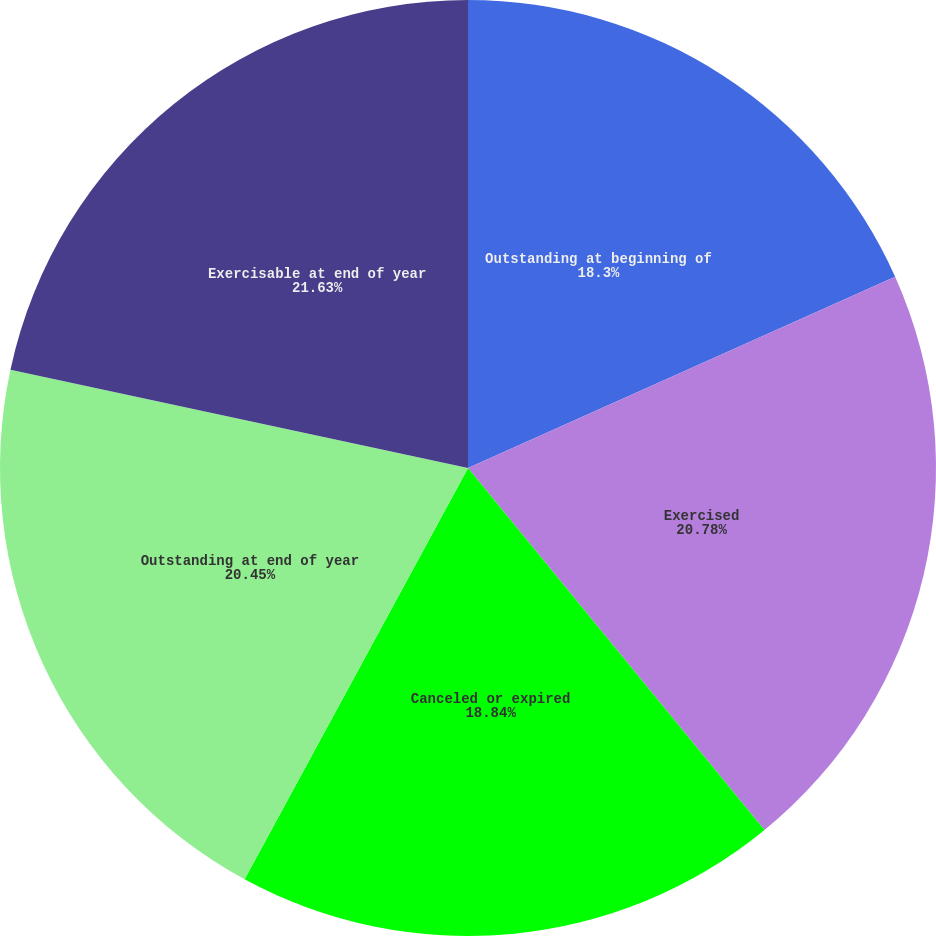<chart> <loc_0><loc_0><loc_500><loc_500><pie_chart><fcel>Outstanding at beginning of<fcel>Exercised<fcel>Canceled or expired<fcel>Outstanding at end of year<fcel>Exercisable at end of year<nl><fcel>18.3%<fcel>20.78%<fcel>18.84%<fcel>20.45%<fcel>21.63%<nl></chart> 